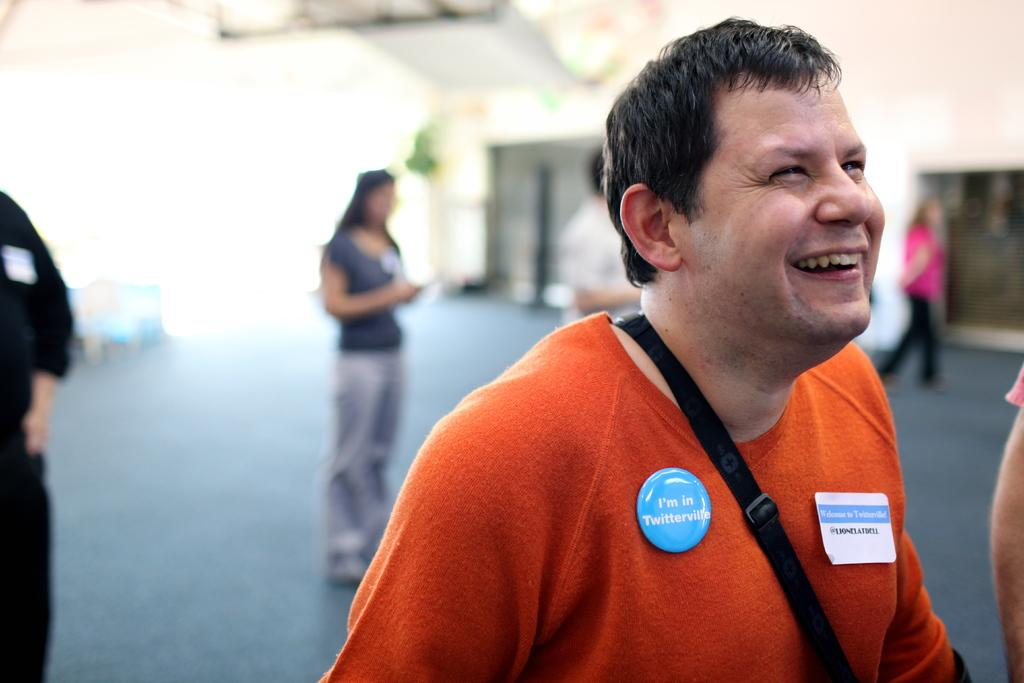Who is the main subject in the image? There is a man in the image. What is the man wearing? The man is wearing an orange T-shirt. What can be seen beneath the man's feet in the image? There is a floor visible in the image. What is the setting of the image? The image appears to be taken in a building. How many people are visible in the background of the image? There are many people in the background of the image. What type of vessel is being used by the man in the image? There is no vessel present in the image; the man is simply standing on a floor. What suggestion does the man make to the people in the background of the image? There is no indication of any suggestion being made by the man in the image. 